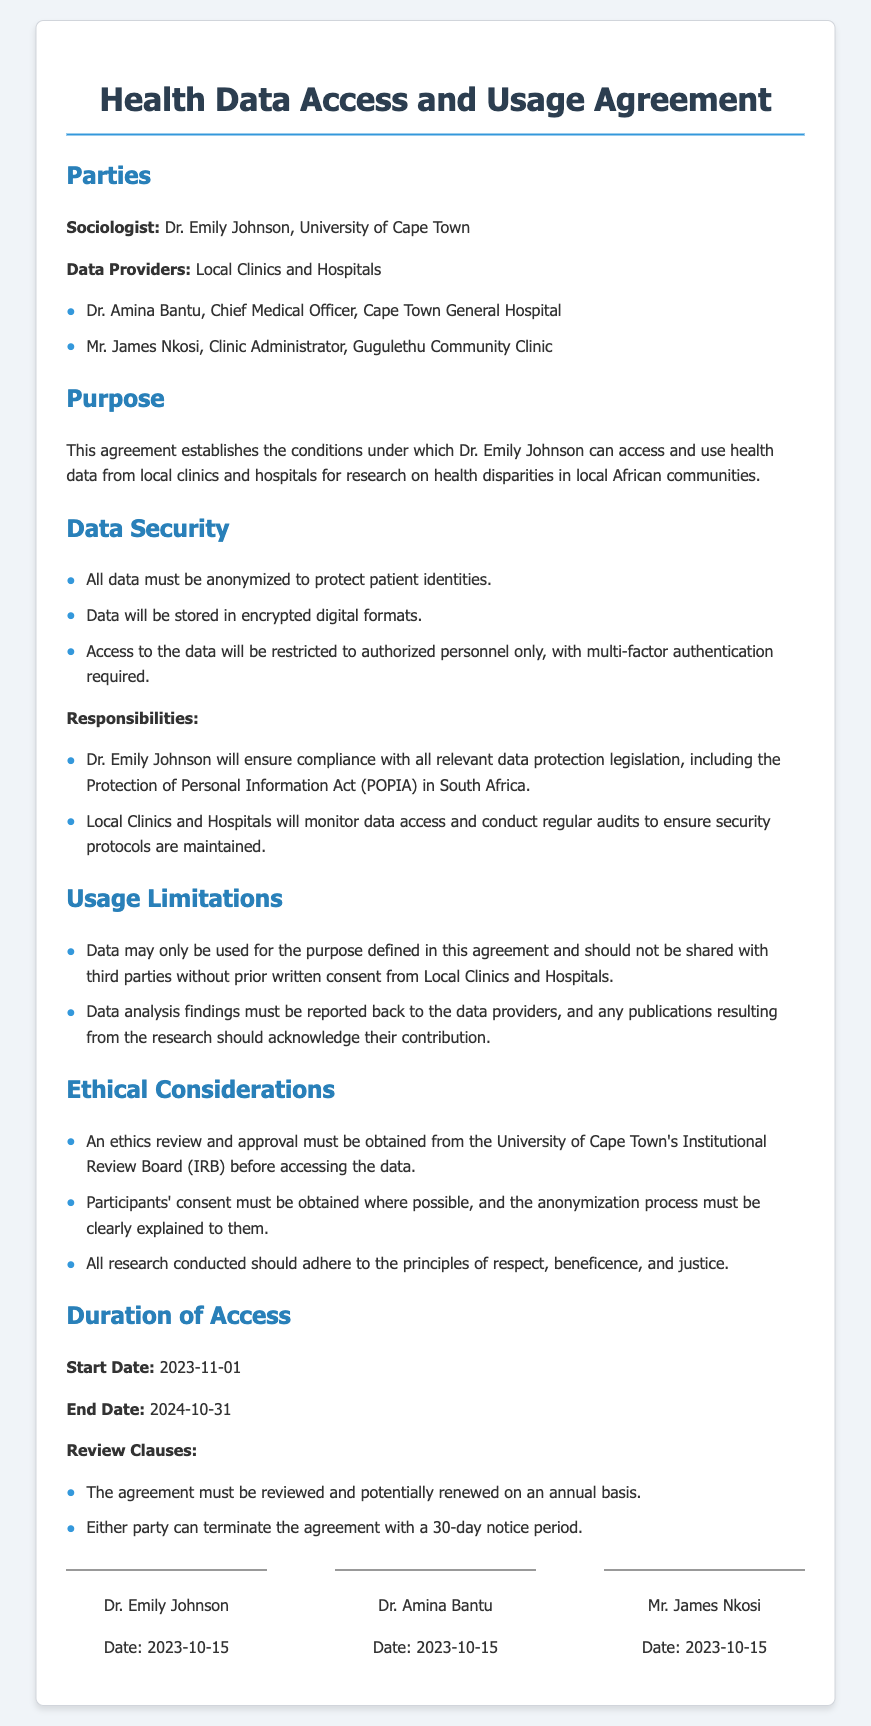What is the name of the sociologist? The sociologist is Dr. Emily Johnson, as mentioned at the beginning of the document.
Answer: Dr. Emily Johnson Who is the Chief Medical Officer of Cape Town General Hospital? The Chief Medical Officer is Dr. Amina Bantu, listed under the Data Providers section.
Answer: Dr. Amina Bantu What is the start date of data access? The start date is specified in the Duration of Access section of the document.
Answer: 2023-11-01 What must be obtained before accessing the data? The document states an ethics review and approval must be obtained from the University of Cape Town's Institutional Review Board.
Answer: Ethics review and approval What does the agreement require regarding data sharing? According to the Usage Limitations section, data should not be shared with third parties without prior written consent.
Answer: Prior written consent How long is the duration of access granted? The duration of access is detailed in the Duration of Access section, specifying the period.
Answer: One year What principle must all research adhere to? The document mentions specific ethical principles that all research should follow.
Answer: Respect, beneficence, and justice Who will monitor data access? The document states that Local Clinics and Hospitals will have the responsibility for monitoring data access.
Answer: Local Clinics and Hospitals 